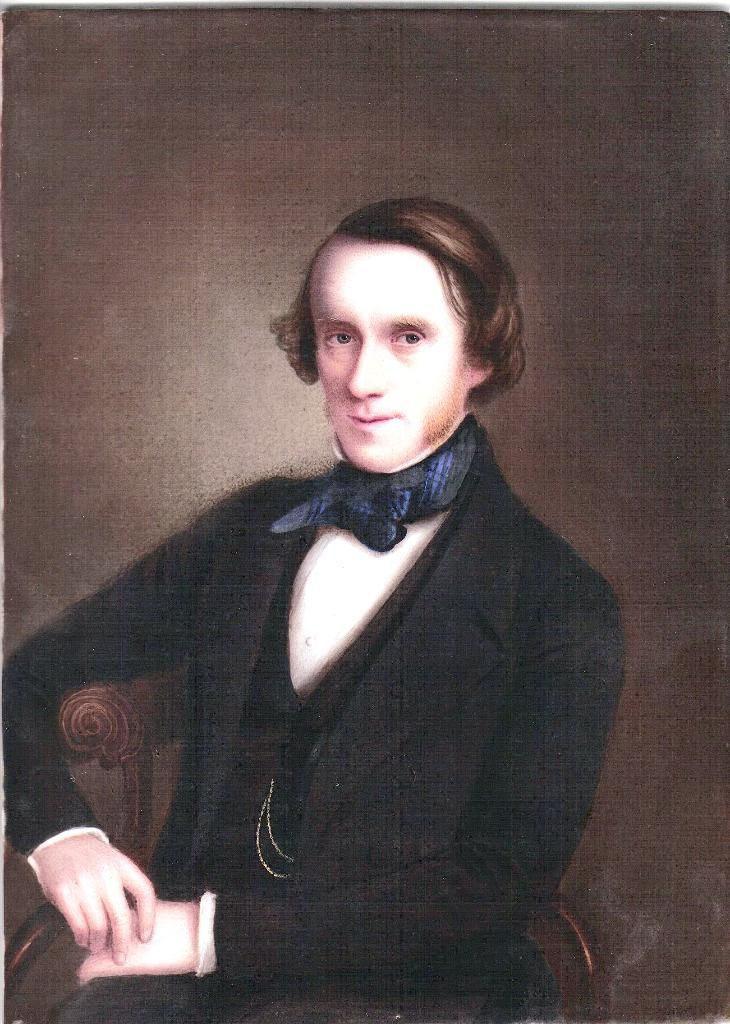Who is present in the image? There is a person in the image. What is the person wearing? The person is wearing a black suit. What is the person doing in the image? The person is sitting in a chair. What type of bath is the person taking in the image? There is no bath present in the image; the person is sitting in a chair wearing a black suit. 